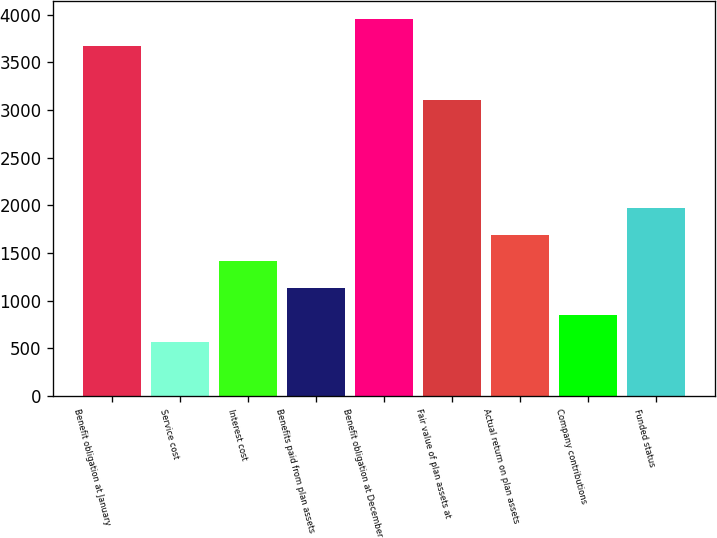<chart> <loc_0><loc_0><loc_500><loc_500><bar_chart><fcel>Benefit obligation at January<fcel>Service cost<fcel>Interest cost<fcel>Benefits paid from plan assets<fcel>Benefit obligation at December<fcel>Fair value of plan assets at<fcel>Actual return on plan assets<fcel>Company contributions<fcel>Funded status<nl><fcel>3666.7<fcel>565.8<fcel>1411.5<fcel>1129.6<fcel>3948.6<fcel>3102.9<fcel>1693.4<fcel>847.7<fcel>1975.3<nl></chart> 